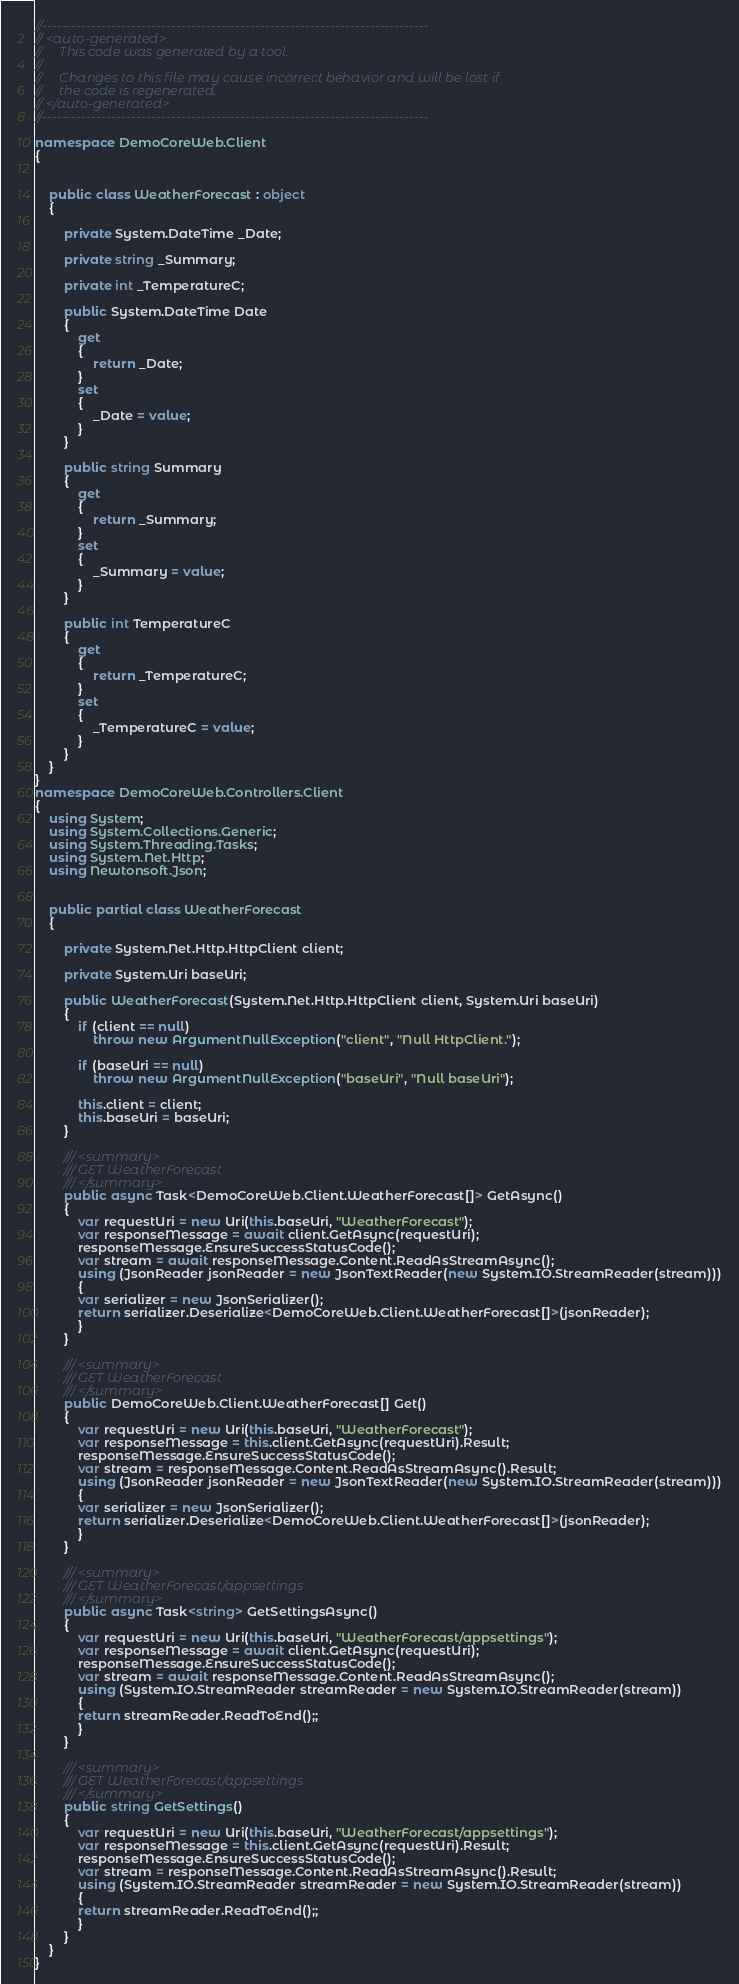<code> <loc_0><loc_0><loc_500><loc_500><_C#_>//------------------------------------------------------------------------------
// <auto-generated>
//     This code was generated by a tool.
//
//     Changes to this file may cause incorrect behavior and will be lost if
//     the code is regenerated.
// </auto-generated>
//------------------------------------------------------------------------------

namespace DemoCoreWeb.Client
{
    
    
    public class WeatherForecast : object
    {
        
        private System.DateTime _Date;
        
        private string _Summary;
        
        private int _TemperatureC;
        
        public System.DateTime Date
        {
            get
            {
                return _Date;
            }
            set
            {
                _Date = value;
            }
        }
        
        public string Summary
        {
            get
            {
                return _Summary;
            }
            set
            {
                _Summary = value;
            }
        }
        
        public int TemperatureC
        {
            get
            {
                return _TemperatureC;
            }
            set
            {
                _TemperatureC = value;
            }
        }
    }
}
namespace DemoCoreWeb.Controllers.Client
{
    using System;
    using System.Collections.Generic;
    using System.Threading.Tasks;
    using System.Net.Http;
    using Newtonsoft.Json;
    
    
    public partial class WeatherForecast
    {
        
        private System.Net.Http.HttpClient client;
        
        private System.Uri baseUri;
        
        public WeatherForecast(System.Net.Http.HttpClient client, System.Uri baseUri)
        {
            if (client == null)
				throw new ArgumentNullException("client", "Null HttpClient.");

            if (baseUri == null)
				throw new ArgumentNullException("baseUri", "Null baseUri");

            this.client = client;
            this.baseUri = baseUri;
        }
        
        /// <summary>
        /// GET WeatherForecast
        /// </summary>
        public async Task<DemoCoreWeb.Client.WeatherForecast[]> GetAsync()
        {
            var requestUri = new Uri(this.baseUri, "WeatherForecast");
            var responseMessage = await client.GetAsync(requestUri);
            responseMessage.EnsureSuccessStatusCode();
            var stream = await responseMessage.Content.ReadAsStreamAsync();
            using (JsonReader jsonReader = new JsonTextReader(new System.IO.StreamReader(stream)))
            {
            var serializer = new JsonSerializer();
            return serializer.Deserialize<DemoCoreWeb.Client.WeatherForecast[]>(jsonReader);
            }
        }
        
        /// <summary>
        /// GET WeatherForecast
        /// </summary>
        public DemoCoreWeb.Client.WeatherForecast[] Get()
        {
            var requestUri = new Uri(this.baseUri, "WeatherForecast");
            var responseMessage = this.client.GetAsync(requestUri).Result;
            responseMessage.EnsureSuccessStatusCode();
            var stream = responseMessage.Content.ReadAsStreamAsync().Result;
            using (JsonReader jsonReader = new JsonTextReader(new System.IO.StreamReader(stream)))
            {
            var serializer = new JsonSerializer();
            return serializer.Deserialize<DemoCoreWeb.Client.WeatherForecast[]>(jsonReader);
            }
        }
        
        /// <summary>
        /// GET WeatherForecast/appsettings
        /// </summary>
        public async Task<string> GetSettingsAsync()
        {
            var requestUri = new Uri(this.baseUri, "WeatherForecast/appsettings");
            var responseMessage = await client.GetAsync(requestUri);
            responseMessage.EnsureSuccessStatusCode();
            var stream = await responseMessage.Content.ReadAsStreamAsync();
            using (System.IO.StreamReader streamReader = new System.IO.StreamReader(stream))
            {
            return streamReader.ReadToEnd();;
            }
        }
        
        /// <summary>
        /// GET WeatherForecast/appsettings
        /// </summary>
        public string GetSettings()
        {
            var requestUri = new Uri(this.baseUri, "WeatherForecast/appsettings");
            var responseMessage = this.client.GetAsync(requestUri).Result;
            responseMessage.EnsureSuccessStatusCode();
            var stream = responseMessage.Content.ReadAsStreamAsync().Result;
            using (System.IO.StreamReader streamReader = new System.IO.StreamReader(stream))
            {
            return streamReader.ReadToEnd();;
            }
        }
    }
}
</code> 